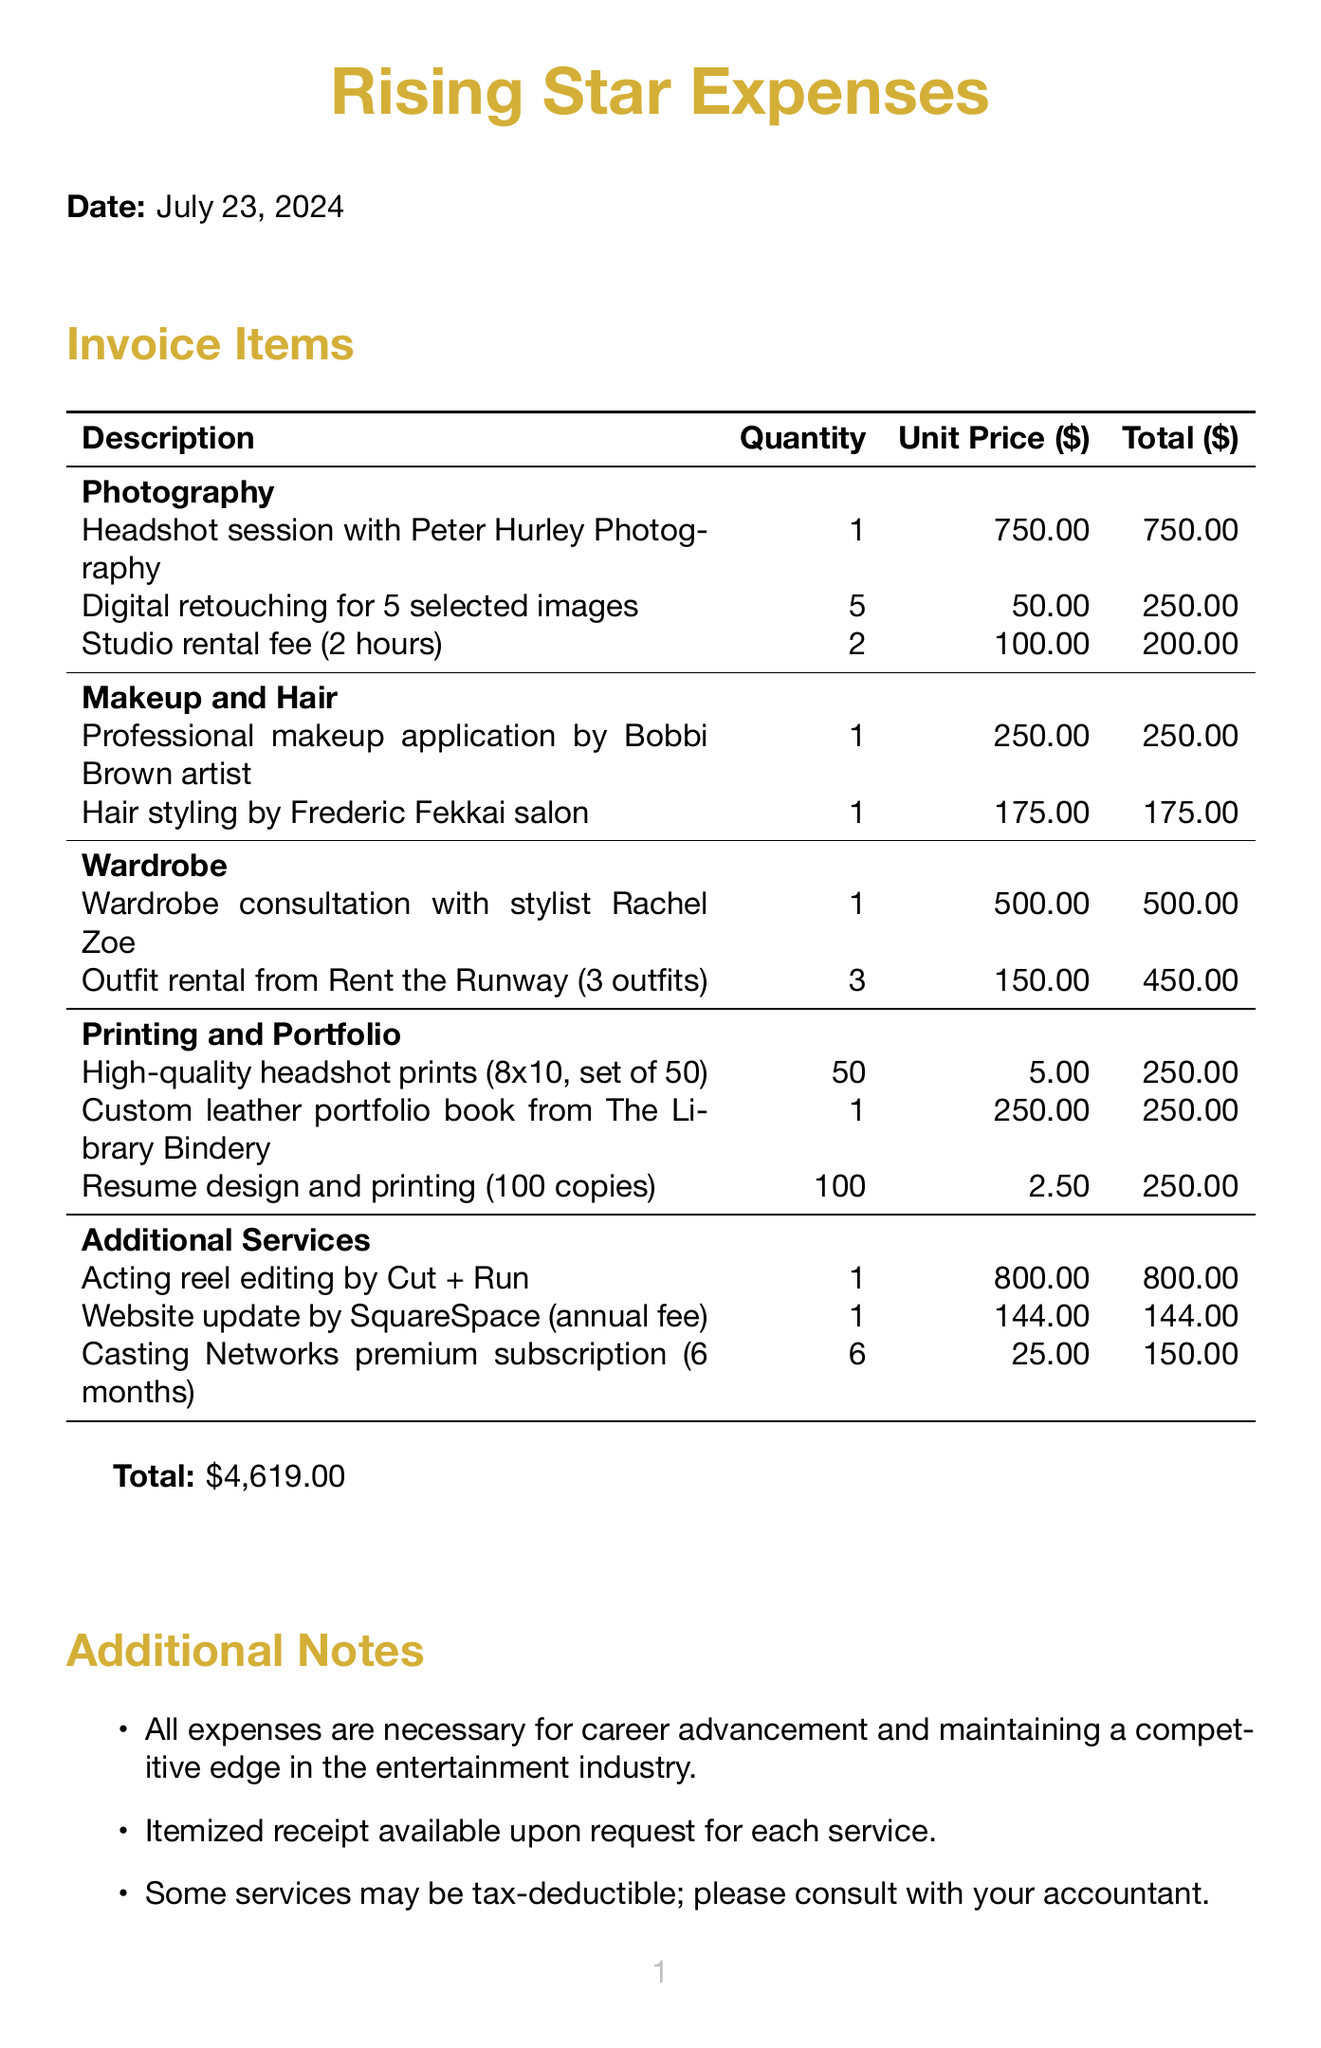What is the total amount for the invoice? The total amount is specified at the bottom of the invoice, which adds up all the expenses listed.
Answer: $4,619.00 Who is the photographer for the headshot session? The document specifies that the headshot session is with Peter Hurley Photography.
Answer: Peter Hurley Photography How many digital retouching images are included? The invoice indicates that there are 5 selected images for digital retouching included in the expense.
Answer: 5 What is the unit price for the custom leather portfolio book? The unit price for the custom leather portfolio book from The Library Bindery is specified in the 'Printing and Portfolio' section.
Answer: $250.00 What services fall under the 'Makeup and Hair' category? The document lists two services under the 'Makeup and Hair' category: Professional makeup application and Hair styling.
Answer: Professional makeup application and Hair styling How much is the studio rental fee for two hours? The fee for studio rental is provided as $100.00 per hour, totaling for 2 hours.
Answer: $200.00 What is mentioned about the tax-deductibility of services? The additional notes indicate that some services may be tax-deductible and recommend consulting with an accountant.
Answer: Some services may be tax-deductible How many outfits are rented from Rent the Runway? The invoice contains information stating that three outfits are rented.
Answer: 3 What type of portfolio service is provided by The Library Bindery? The invoice specifies that a custom leather portfolio book is a service provided by The Library Bindery.
Answer: Custom leather portfolio book 